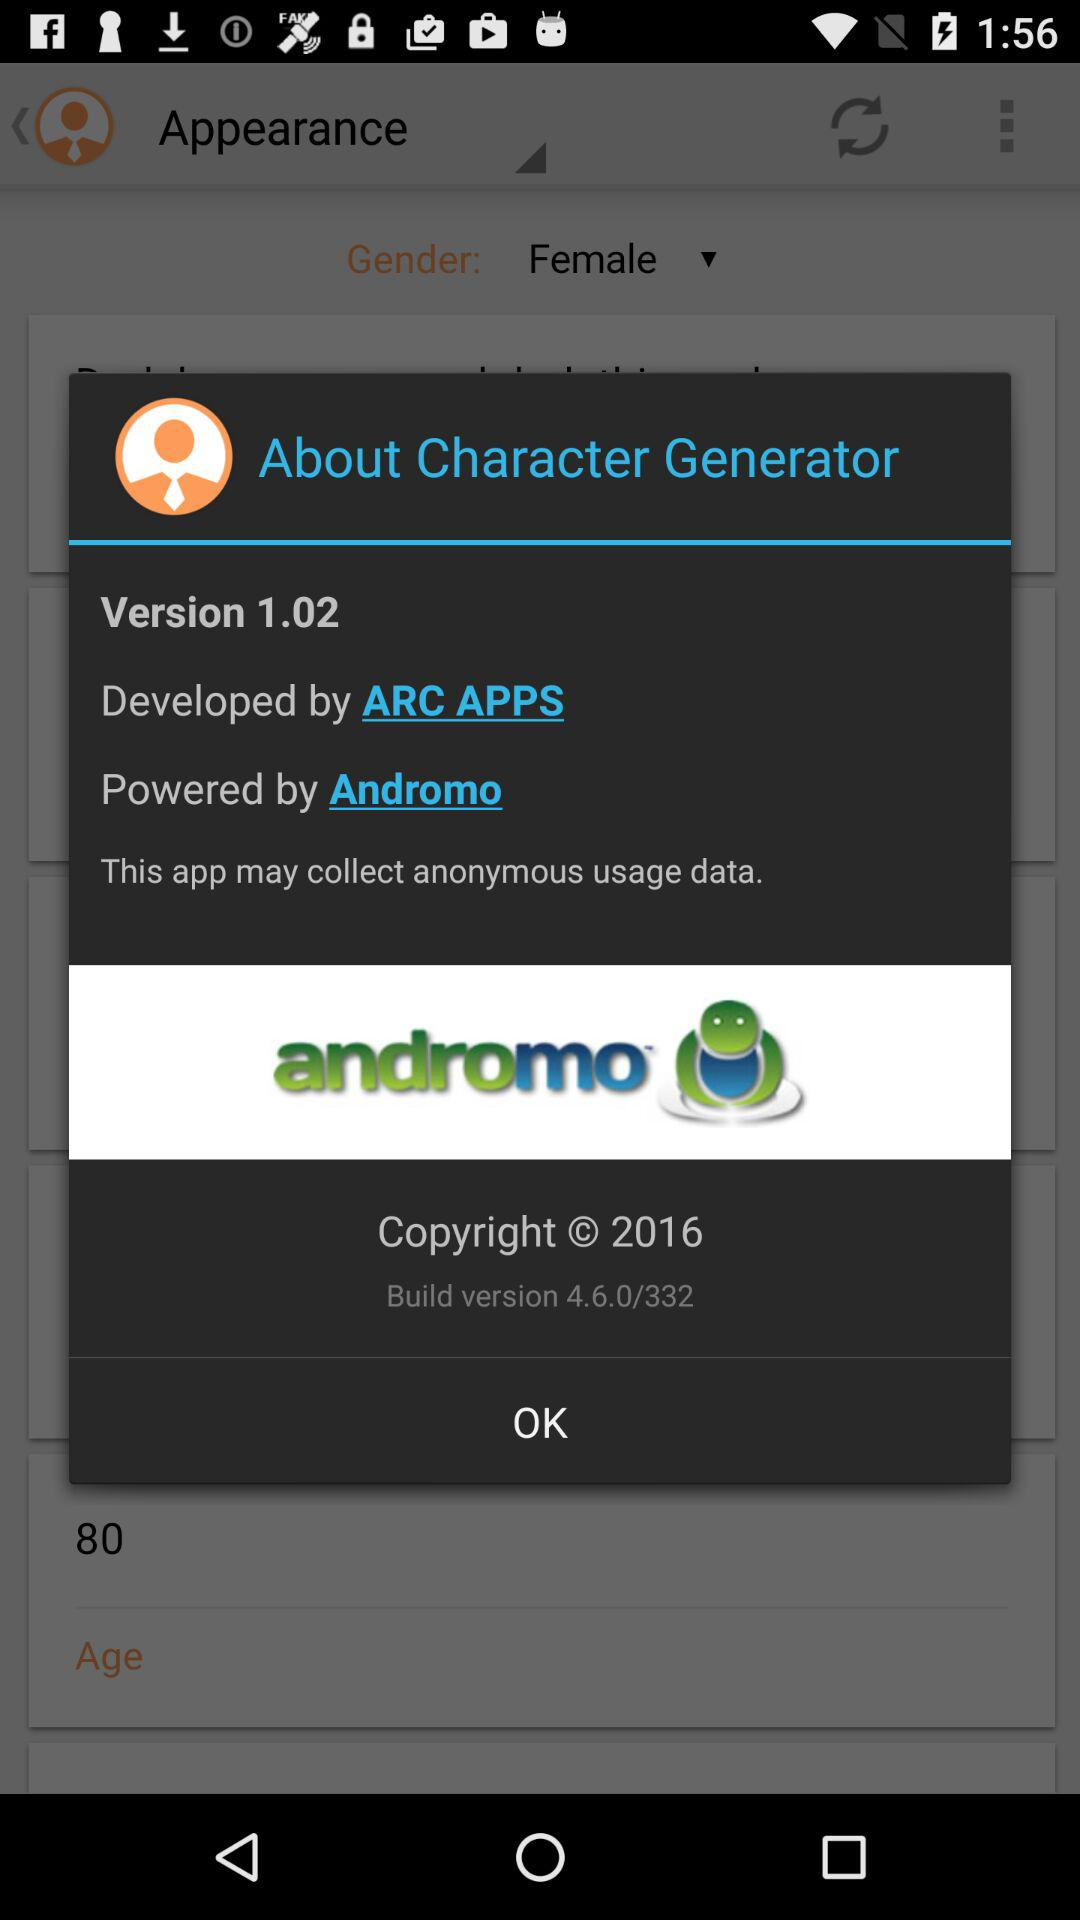By whom is the "Character Generator" application powered? The "Character Generator" application is powered by "Andromo". 